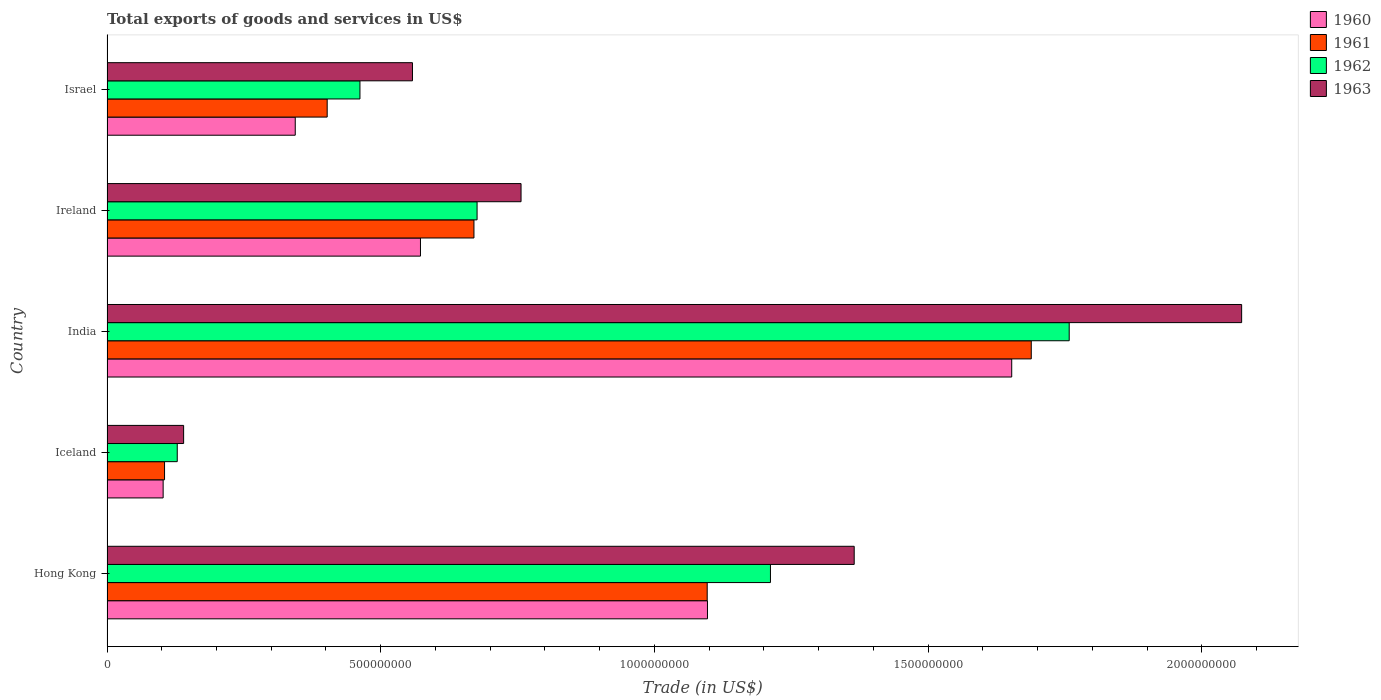How many different coloured bars are there?
Your answer should be compact. 4. How many groups of bars are there?
Offer a very short reply. 5. Are the number of bars on each tick of the Y-axis equal?
Give a very brief answer. Yes. How many bars are there on the 1st tick from the top?
Your response must be concise. 4. What is the label of the 4th group of bars from the top?
Offer a terse response. Iceland. What is the total exports of goods and services in 1960 in Israel?
Your answer should be very brief. 3.44e+08. Across all countries, what is the maximum total exports of goods and services in 1961?
Offer a terse response. 1.69e+09. Across all countries, what is the minimum total exports of goods and services in 1961?
Provide a succinct answer. 1.05e+08. In which country was the total exports of goods and services in 1960 maximum?
Provide a short and direct response. India. In which country was the total exports of goods and services in 1963 minimum?
Your response must be concise. Iceland. What is the total total exports of goods and services in 1961 in the graph?
Ensure brevity in your answer.  3.96e+09. What is the difference between the total exports of goods and services in 1963 in Hong Kong and that in Iceland?
Your answer should be compact. 1.22e+09. What is the difference between the total exports of goods and services in 1961 in India and the total exports of goods and services in 1963 in Iceland?
Provide a succinct answer. 1.55e+09. What is the average total exports of goods and services in 1962 per country?
Your answer should be compact. 8.47e+08. What is the difference between the total exports of goods and services in 1962 and total exports of goods and services in 1960 in Iceland?
Your answer should be very brief. 2.58e+07. What is the ratio of the total exports of goods and services in 1960 in Hong Kong to that in Iceland?
Provide a succinct answer. 10.7. Is the total exports of goods and services in 1962 in Hong Kong less than that in Ireland?
Make the answer very short. No. What is the difference between the highest and the second highest total exports of goods and services in 1963?
Make the answer very short. 7.08e+08. What is the difference between the highest and the lowest total exports of goods and services in 1962?
Offer a terse response. 1.63e+09. In how many countries, is the total exports of goods and services in 1961 greater than the average total exports of goods and services in 1961 taken over all countries?
Offer a terse response. 2. Is the sum of the total exports of goods and services in 1961 in India and Israel greater than the maximum total exports of goods and services in 1962 across all countries?
Ensure brevity in your answer.  Yes. What does the 1st bar from the top in Iceland represents?
Ensure brevity in your answer.  1963. What does the 1st bar from the bottom in Hong Kong represents?
Offer a terse response. 1960. Is it the case that in every country, the sum of the total exports of goods and services in 1963 and total exports of goods and services in 1962 is greater than the total exports of goods and services in 1961?
Your answer should be compact. Yes. How many bars are there?
Make the answer very short. 20. How many countries are there in the graph?
Your response must be concise. 5. What is the difference between two consecutive major ticks on the X-axis?
Your answer should be very brief. 5.00e+08. How are the legend labels stacked?
Your answer should be compact. Vertical. What is the title of the graph?
Your answer should be very brief. Total exports of goods and services in US$. What is the label or title of the X-axis?
Your answer should be very brief. Trade (in US$). What is the Trade (in US$) of 1960 in Hong Kong?
Provide a short and direct response. 1.10e+09. What is the Trade (in US$) in 1961 in Hong Kong?
Provide a short and direct response. 1.10e+09. What is the Trade (in US$) of 1962 in Hong Kong?
Ensure brevity in your answer.  1.21e+09. What is the Trade (in US$) in 1963 in Hong Kong?
Offer a very short reply. 1.36e+09. What is the Trade (in US$) in 1960 in Iceland?
Keep it short and to the point. 1.03e+08. What is the Trade (in US$) of 1961 in Iceland?
Your answer should be compact. 1.05e+08. What is the Trade (in US$) of 1962 in Iceland?
Your answer should be compact. 1.28e+08. What is the Trade (in US$) in 1963 in Iceland?
Your response must be concise. 1.40e+08. What is the Trade (in US$) of 1960 in India?
Give a very brief answer. 1.65e+09. What is the Trade (in US$) of 1961 in India?
Make the answer very short. 1.69e+09. What is the Trade (in US$) of 1962 in India?
Your answer should be very brief. 1.76e+09. What is the Trade (in US$) of 1963 in India?
Provide a short and direct response. 2.07e+09. What is the Trade (in US$) in 1960 in Ireland?
Ensure brevity in your answer.  5.73e+08. What is the Trade (in US$) in 1961 in Ireland?
Your answer should be compact. 6.70e+08. What is the Trade (in US$) of 1962 in Ireland?
Make the answer very short. 6.76e+08. What is the Trade (in US$) of 1963 in Ireland?
Provide a short and direct response. 7.56e+08. What is the Trade (in US$) in 1960 in Israel?
Your answer should be very brief. 3.44e+08. What is the Trade (in US$) of 1961 in Israel?
Make the answer very short. 4.02e+08. What is the Trade (in US$) in 1962 in Israel?
Provide a short and direct response. 4.62e+08. What is the Trade (in US$) of 1963 in Israel?
Your response must be concise. 5.58e+08. Across all countries, what is the maximum Trade (in US$) in 1960?
Make the answer very short. 1.65e+09. Across all countries, what is the maximum Trade (in US$) of 1961?
Your response must be concise. 1.69e+09. Across all countries, what is the maximum Trade (in US$) of 1962?
Provide a succinct answer. 1.76e+09. Across all countries, what is the maximum Trade (in US$) in 1963?
Keep it short and to the point. 2.07e+09. Across all countries, what is the minimum Trade (in US$) of 1960?
Give a very brief answer. 1.03e+08. Across all countries, what is the minimum Trade (in US$) in 1961?
Provide a succinct answer. 1.05e+08. Across all countries, what is the minimum Trade (in US$) in 1962?
Your answer should be compact. 1.28e+08. Across all countries, what is the minimum Trade (in US$) in 1963?
Keep it short and to the point. 1.40e+08. What is the total Trade (in US$) in 1960 in the graph?
Ensure brevity in your answer.  3.77e+09. What is the total Trade (in US$) in 1961 in the graph?
Make the answer very short. 3.96e+09. What is the total Trade (in US$) in 1962 in the graph?
Provide a short and direct response. 4.24e+09. What is the total Trade (in US$) in 1963 in the graph?
Ensure brevity in your answer.  4.89e+09. What is the difference between the Trade (in US$) in 1960 in Hong Kong and that in Iceland?
Your answer should be compact. 9.94e+08. What is the difference between the Trade (in US$) of 1961 in Hong Kong and that in Iceland?
Provide a short and direct response. 9.91e+08. What is the difference between the Trade (in US$) of 1962 in Hong Kong and that in Iceland?
Your response must be concise. 1.08e+09. What is the difference between the Trade (in US$) of 1963 in Hong Kong and that in Iceland?
Your response must be concise. 1.22e+09. What is the difference between the Trade (in US$) in 1960 in Hong Kong and that in India?
Keep it short and to the point. -5.56e+08. What is the difference between the Trade (in US$) of 1961 in Hong Kong and that in India?
Offer a very short reply. -5.92e+08. What is the difference between the Trade (in US$) of 1962 in Hong Kong and that in India?
Provide a succinct answer. -5.46e+08. What is the difference between the Trade (in US$) of 1963 in Hong Kong and that in India?
Provide a succinct answer. -7.08e+08. What is the difference between the Trade (in US$) in 1960 in Hong Kong and that in Ireland?
Offer a very short reply. 5.24e+08. What is the difference between the Trade (in US$) of 1961 in Hong Kong and that in Ireland?
Offer a terse response. 4.26e+08. What is the difference between the Trade (in US$) of 1962 in Hong Kong and that in Ireland?
Your answer should be very brief. 5.36e+08. What is the difference between the Trade (in US$) of 1963 in Hong Kong and that in Ireland?
Ensure brevity in your answer.  6.09e+08. What is the difference between the Trade (in US$) of 1960 in Hong Kong and that in Israel?
Make the answer very short. 7.53e+08. What is the difference between the Trade (in US$) of 1961 in Hong Kong and that in Israel?
Provide a short and direct response. 6.94e+08. What is the difference between the Trade (in US$) of 1962 in Hong Kong and that in Israel?
Offer a very short reply. 7.50e+08. What is the difference between the Trade (in US$) in 1963 in Hong Kong and that in Israel?
Your response must be concise. 8.07e+08. What is the difference between the Trade (in US$) of 1960 in Iceland and that in India?
Provide a succinct answer. -1.55e+09. What is the difference between the Trade (in US$) of 1961 in Iceland and that in India?
Your answer should be compact. -1.58e+09. What is the difference between the Trade (in US$) in 1962 in Iceland and that in India?
Give a very brief answer. -1.63e+09. What is the difference between the Trade (in US$) of 1963 in Iceland and that in India?
Offer a very short reply. -1.93e+09. What is the difference between the Trade (in US$) of 1960 in Iceland and that in Ireland?
Your answer should be very brief. -4.70e+08. What is the difference between the Trade (in US$) in 1961 in Iceland and that in Ireland?
Your response must be concise. -5.65e+08. What is the difference between the Trade (in US$) of 1962 in Iceland and that in Ireland?
Your answer should be compact. -5.48e+08. What is the difference between the Trade (in US$) in 1963 in Iceland and that in Ireland?
Your answer should be very brief. -6.16e+08. What is the difference between the Trade (in US$) in 1960 in Iceland and that in Israel?
Offer a terse response. -2.41e+08. What is the difference between the Trade (in US$) of 1961 in Iceland and that in Israel?
Give a very brief answer. -2.97e+08. What is the difference between the Trade (in US$) in 1962 in Iceland and that in Israel?
Give a very brief answer. -3.34e+08. What is the difference between the Trade (in US$) in 1963 in Iceland and that in Israel?
Your response must be concise. -4.18e+08. What is the difference between the Trade (in US$) of 1960 in India and that in Ireland?
Offer a terse response. 1.08e+09. What is the difference between the Trade (in US$) in 1961 in India and that in Ireland?
Your answer should be very brief. 1.02e+09. What is the difference between the Trade (in US$) in 1962 in India and that in Ireland?
Make the answer very short. 1.08e+09. What is the difference between the Trade (in US$) in 1963 in India and that in Ireland?
Ensure brevity in your answer.  1.32e+09. What is the difference between the Trade (in US$) of 1960 in India and that in Israel?
Your answer should be very brief. 1.31e+09. What is the difference between the Trade (in US$) of 1961 in India and that in Israel?
Offer a terse response. 1.29e+09. What is the difference between the Trade (in US$) in 1962 in India and that in Israel?
Provide a succinct answer. 1.30e+09. What is the difference between the Trade (in US$) of 1963 in India and that in Israel?
Keep it short and to the point. 1.51e+09. What is the difference between the Trade (in US$) in 1960 in Ireland and that in Israel?
Give a very brief answer. 2.29e+08. What is the difference between the Trade (in US$) in 1961 in Ireland and that in Israel?
Provide a succinct answer. 2.68e+08. What is the difference between the Trade (in US$) in 1962 in Ireland and that in Israel?
Your answer should be compact. 2.14e+08. What is the difference between the Trade (in US$) in 1963 in Ireland and that in Israel?
Make the answer very short. 1.98e+08. What is the difference between the Trade (in US$) in 1960 in Hong Kong and the Trade (in US$) in 1961 in Iceland?
Give a very brief answer. 9.92e+08. What is the difference between the Trade (in US$) of 1960 in Hong Kong and the Trade (in US$) of 1962 in Iceland?
Make the answer very short. 9.69e+08. What is the difference between the Trade (in US$) of 1960 in Hong Kong and the Trade (in US$) of 1963 in Iceland?
Provide a short and direct response. 9.57e+08. What is the difference between the Trade (in US$) of 1961 in Hong Kong and the Trade (in US$) of 1962 in Iceland?
Ensure brevity in your answer.  9.68e+08. What is the difference between the Trade (in US$) in 1961 in Hong Kong and the Trade (in US$) in 1963 in Iceland?
Ensure brevity in your answer.  9.56e+08. What is the difference between the Trade (in US$) of 1962 in Hong Kong and the Trade (in US$) of 1963 in Iceland?
Offer a very short reply. 1.07e+09. What is the difference between the Trade (in US$) in 1960 in Hong Kong and the Trade (in US$) in 1961 in India?
Offer a terse response. -5.91e+08. What is the difference between the Trade (in US$) in 1960 in Hong Kong and the Trade (in US$) in 1962 in India?
Your answer should be compact. -6.61e+08. What is the difference between the Trade (in US$) in 1960 in Hong Kong and the Trade (in US$) in 1963 in India?
Your response must be concise. -9.76e+08. What is the difference between the Trade (in US$) of 1961 in Hong Kong and the Trade (in US$) of 1962 in India?
Offer a very short reply. -6.61e+08. What is the difference between the Trade (in US$) of 1961 in Hong Kong and the Trade (in US$) of 1963 in India?
Your response must be concise. -9.76e+08. What is the difference between the Trade (in US$) of 1962 in Hong Kong and the Trade (in US$) of 1963 in India?
Your answer should be compact. -8.61e+08. What is the difference between the Trade (in US$) in 1960 in Hong Kong and the Trade (in US$) in 1961 in Ireland?
Offer a very short reply. 4.27e+08. What is the difference between the Trade (in US$) of 1960 in Hong Kong and the Trade (in US$) of 1962 in Ireland?
Provide a succinct answer. 4.21e+08. What is the difference between the Trade (in US$) of 1960 in Hong Kong and the Trade (in US$) of 1963 in Ireland?
Provide a short and direct response. 3.41e+08. What is the difference between the Trade (in US$) of 1961 in Hong Kong and the Trade (in US$) of 1962 in Ireland?
Your answer should be very brief. 4.20e+08. What is the difference between the Trade (in US$) of 1961 in Hong Kong and the Trade (in US$) of 1963 in Ireland?
Offer a terse response. 3.40e+08. What is the difference between the Trade (in US$) in 1962 in Hong Kong and the Trade (in US$) in 1963 in Ireland?
Your answer should be very brief. 4.56e+08. What is the difference between the Trade (in US$) of 1960 in Hong Kong and the Trade (in US$) of 1961 in Israel?
Offer a terse response. 6.95e+08. What is the difference between the Trade (in US$) in 1960 in Hong Kong and the Trade (in US$) in 1962 in Israel?
Your answer should be very brief. 6.35e+08. What is the difference between the Trade (in US$) of 1960 in Hong Kong and the Trade (in US$) of 1963 in Israel?
Offer a very short reply. 5.39e+08. What is the difference between the Trade (in US$) of 1961 in Hong Kong and the Trade (in US$) of 1962 in Israel?
Offer a terse response. 6.34e+08. What is the difference between the Trade (in US$) of 1961 in Hong Kong and the Trade (in US$) of 1963 in Israel?
Ensure brevity in your answer.  5.38e+08. What is the difference between the Trade (in US$) in 1962 in Hong Kong and the Trade (in US$) in 1963 in Israel?
Your answer should be very brief. 6.54e+08. What is the difference between the Trade (in US$) of 1960 in Iceland and the Trade (in US$) of 1961 in India?
Provide a succinct answer. -1.59e+09. What is the difference between the Trade (in US$) of 1960 in Iceland and the Trade (in US$) of 1962 in India?
Provide a short and direct response. -1.66e+09. What is the difference between the Trade (in US$) of 1960 in Iceland and the Trade (in US$) of 1963 in India?
Your answer should be compact. -1.97e+09. What is the difference between the Trade (in US$) of 1961 in Iceland and the Trade (in US$) of 1962 in India?
Ensure brevity in your answer.  -1.65e+09. What is the difference between the Trade (in US$) in 1961 in Iceland and the Trade (in US$) in 1963 in India?
Give a very brief answer. -1.97e+09. What is the difference between the Trade (in US$) in 1962 in Iceland and the Trade (in US$) in 1963 in India?
Provide a short and direct response. -1.94e+09. What is the difference between the Trade (in US$) in 1960 in Iceland and the Trade (in US$) in 1961 in Ireland?
Keep it short and to the point. -5.68e+08. What is the difference between the Trade (in US$) of 1960 in Iceland and the Trade (in US$) of 1962 in Ireland?
Provide a short and direct response. -5.73e+08. What is the difference between the Trade (in US$) in 1960 in Iceland and the Trade (in US$) in 1963 in Ireland?
Your answer should be very brief. -6.54e+08. What is the difference between the Trade (in US$) in 1961 in Iceland and the Trade (in US$) in 1962 in Ireland?
Keep it short and to the point. -5.71e+08. What is the difference between the Trade (in US$) of 1961 in Iceland and the Trade (in US$) of 1963 in Ireland?
Offer a very short reply. -6.51e+08. What is the difference between the Trade (in US$) in 1962 in Iceland and the Trade (in US$) in 1963 in Ireland?
Your answer should be compact. -6.28e+08. What is the difference between the Trade (in US$) in 1960 in Iceland and the Trade (in US$) in 1961 in Israel?
Offer a terse response. -3.00e+08. What is the difference between the Trade (in US$) in 1960 in Iceland and the Trade (in US$) in 1962 in Israel?
Your answer should be very brief. -3.60e+08. What is the difference between the Trade (in US$) in 1960 in Iceland and the Trade (in US$) in 1963 in Israel?
Your answer should be compact. -4.55e+08. What is the difference between the Trade (in US$) of 1961 in Iceland and the Trade (in US$) of 1962 in Israel?
Your answer should be very brief. -3.57e+08. What is the difference between the Trade (in US$) in 1961 in Iceland and the Trade (in US$) in 1963 in Israel?
Make the answer very short. -4.53e+08. What is the difference between the Trade (in US$) in 1962 in Iceland and the Trade (in US$) in 1963 in Israel?
Keep it short and to the point. -4.30e+08. What is the difference between the Trade (in US$) of 1960 in India and the Trade (in US$) of 1961 in Ireland?
Your response must be concise. 9.82e+08. What is the difference between the Trade (in US$) in 1960 in India and the Trade (in US$) in 1962 in Ireland?
Provide a succinct answer. 9.77e+08. What is the difference between the Trade (in US$) in 1960 in India and the Trade (in US$) in 1963 in Ireland?
Ensure brevity in your answer.  8.96e+08. What is the difference between the Trade (in US$) of 1961 in India and the Trade (in US$) of 1962 in Ireland?
Your answer should be very brief. 1.01e+09. What is the difference between the Trade (in US$) of 1961 in India and the Trade (in US$) of 1963 in Ireland?
Offer a very short reply. 9.32e+08. What is the difference between the Trade (in US$) in 1962 in India and the Trade (in US$) in 1963 in Ireland?
Your answer should be compact. 1.00e+09. What is the difference between the Trade (in US$) in 1960 in India and the Trade (in US$) in 1961 in Israel?
Ensure brevity in your answer.  1.25e+09. What is the difference between the Trade (in US$) of 1960 in India and the Trade (in US$) of 1962 in Israel?
Provide a succinct answer. 1.19e+09. What is the difference between the Trade (in US$) in 1960 in India and the Trade (in US$) in 1963 in Israel?
Offer a very short reply. 1.09e+09. What is the difference between the Trade (in US$) of 1961 in India and the Trade (in US$) of 1962 in Israel?
Provide a short and direct response. 1.23e+09. What is the difference between the Trade (in US$) in 1961 in India and the Trade (in US$) in 1963 in Israel?
Offer a terse response. 1.13e+09. What is the difference between the Trade (in US$) in 1962 in India and the Trade (in US$) in 1963 in Israel?
Give a very brief answer. 1.20e+09. What is the difference between the Trade (in US$) of 1960 in Ireland and the Trade (in US$) of 1961 in Israel?
Ensure brevity in your answer.  1.70e+08. What is the difference between the Trade (in US$) in 1960 in Ireland and the Trade (in US$) in 1962 in Israel?
Keep it short and to the point. 1.11e+08. What is the difference between the Trade (in US$) in 1960 in Ireland and the Trade (in US$) in 1963 in Israel?
Ensure brevity in your answer.  1.46e+07. What is the difference between the Trade (in US$) of 1961 in Ireland and the Trade (in US$) of 1962 in Israel?
Provide a short and direct response. 2.08e+08. What is the difference between the Trade (in US$) of 1961 in Ireland and the Trade (in US$) of 1963 in Israel?
Keep it short and to the point. 1.12e+08. What is the difference between the Trade (in US$) of 1962 in Ireland and the Trade (in US$) of 1963 in Israel?
Your answer should be compact. 1.18e+08. What is the average Trade (in US$) of 1960 per country?
Provide a succinct answer. 7.54e+08. What is the average Trade (in US$) of 1961 per country?
Offer a terse response. 7.92e+08. What is the average Trade (in US$) of 1962 per country?
Provide a short and direct response. 8.47e+08. What is the average Trade (in US$) of 1963 per country?
Provide a short and direct response. 9.78e+08. What is the difference between the Trade (in US$) in 1960 and Trade (in US$) in 1961 in Hong Kong?
Provide a short and direct response. 4.96e+05. What is the difference between the Trade (in US$) in 1960 and Trade (in US$) in 1962 in Hong Kong?
Your answer should be compact. -1.15e+08. What is the difference between the Trade (in US$) in 1960 and Trade (in US$) in 1963 in Hong Kong?
Make the answer very short. -2.68e+08. What is the difference between the Trade (in US$) of 1961 and Trade (in US$) of 1962 in Hong Kong?
Your response must be concise. -1.16e+08. What is the difference between the Trade (in US$) in 1961 and Trade (in US$) in 1963 in Hong Kong?
Your answer should be compact. -2.69e+08. What is the difference between the Trade (in US$) of 1962 and Trade (in US$) of 1963 in Hong Kong?
Offer a very short reply. -1.53e+08. What is the difference between the Trade (in US$) in 1960 and Trade (in US$) in 1961 in Iceland?
Provide a succinct answer. -2.55e+06. What is the difference between the Trade (in US$) in 1960 and Trade (in US$) in 1962 in Iceland?
Keep it short and to the point. -2.58e+07. What is the difference between the Trade (in US$) of 1960 and Trade (in US$) of 1963 in Iceland?
Provide a succinct answer. -3.74e+07. What is the difference between the Trade (in US$) of 1961 and Trade (in US$) of 1962 in Iceland?
Provide a succinct answer. -2.32e+07. What is the difference between the Trade (in US$) in 1961 and Trade (in US$) in 1963 in Iceland?
Provide a short and direct response. -3.49e+07. What is the difference between the Trade (in US$) in 1962 and Trade (in US$) in 1963 in Iceland?
Provide a succinct answer. -1.17e+07. What is the difference between the Trade (in US$) of 1960 and Trade (in US$) of 1961 in India?
Offer a very short reply. -3.57e+07. What is the difference between the Trade (in US$) in 1960 and Trade (in US$) in 1962 in India?
Keep it short and to the point. -1.05e+08. What is the difference between the Trade (in US$) of 1960 and Trade (in US$) of 1963 in India?
Give a very brief answer. -4.20e+08. What is the difference between the Trade (in US$) in 1961 and Trade (in US$) in 1962 in India?
Give a very brief answer. -6.93e+07. What is the difference between the Trade (in US$) of 1961 and Trade (in US$) of 1963 in India?
Ensure brevity in your answer.  -3.84e+08. What is the difference between the Trade (in US$) of 1962 and Trade (in US$) of 1963 in India?
Provide a succinct answer. -3.15e+08. What is the difference between the Trade (in US$) of 1960 and Trade (in US$) of 1961 in Ireland?
Ensure brevity in your answer.  -9.77e+07. What is the difference between the Trade (in US$) of 1960 and Trade (in US$) of 1962 in Ireland?
Offer a terse response. -1.03e+08. What is the difference between the Trade (in US$) in 1960 and Trade (in US$) in 1963 in Ireland?
Provide a succinct answer. -1.84e+08. What is the difference between the Trade (in US$) of 1961 and Trade (in US$) of 1962 in Ireland?
Offer a very short reply. -5.70e+06. What is the difference between the Trade (in US$) of 1961 and Trade (in US$) of 1963 in Ireland?
Your answer should be compact. -8.60e+07. What is the difference between the Trade (in US$) of 1962 and Trade (in US$) of 1963 in Ireland?
Offer a very short reply. -8.03e+07. What is the difference between the Trade (in US$) of 1960 and Trade (in US$) of 1961 in Israel?
Give a very brief answer. -5.83e+07. What is the difference between the Trade (in US$) in 1960 and Trade (in US$) in 1962 in Israel?
Your response must be concise. -1.18e+08. What is the difference between the Trade (in US$) of 1960 and Trade (in US$) of 1963 in Israel?
Your answer should be very brief. -2.14e+08. What is the difference between the Trade (in US$) of 1961 and Trade (in US$) of 1962 in Israel?
Your answer should be compact. -5.98e+07. What is the difference between the Trade (in US$) in 1961 and Trade (in US$) in 1963 in Israel?
Ensure brevity in your answer.  -1.56e+08. What is the difference between the Trade (in US$) of 1962 and Trade (in US$) of 1963 in Israel?
Keep it short and to the point. -9.59e+07. What is the ratio of the Trade (in US$) of 1960 in Hong Kong to that in Iceland?
Your answer should be very brief. 10.7. What is the ratio of the Trade (in US$) in 1961 in Hong Kong to that in Iceland?
Ensure brevity in your answer.  10.43. What is the ratio of the Trade (in US$) of 1962 in Hong Kong to that in Iceland?
Provide a succinct answer. 9.45. What is the ratio of the Trade (in US$) of 1963 in Hong Kong to that in Iceland?
Your answer should be compact. 9.75. What is the ratio of the Trade (in US$) of 1960 in Hong Kong to that in India?
Make the answer very short. 0.66. What is the ratio of the Trade (in US$) in 1961 in Hong Kong to that in India?
Make the answer very short. 0.65. What is the ratio of the Trade (in US$) in 1962 in Hong Kong to that in India?
Give a very brief answer. 0.69. What is the ratio of the Trade (in US$) of 1963 in Hong Kong to that in India?
Ensure brevity in your answer.  0.66. What is the ratio of the Trade (in US$) of 1960 in Hong Kong to that in Ireland?
Your answer should be compact. 1.92. What is the ratio of the Trade (in US$) in 1961 in Hong Kong to that in Ireland?
Offer a very short reply. 1.64. What is the ratio of the Trade (in US$) of 1962 in Hong Kong to that in Ireland?
Offer a terse response. 1.79. What is the ratio of the Trade (in US$) of 1963 in Hong Kong to that in Ireland?
Offer a very short reply. 1.8. What is the ratio of the Trade (in US$) in 1960 in Hong Kong to that in Israel?
Give a very brief answer. 3.19. What is the ratio of the Trade (in US$) in 1961 in Hong Kong to that in Israel?
Offer a terse response. 2.73. What is the ratio of the Trade (in US$) of 1962 in Hong Kong to that in Israel?
Your response must be concise. 2.62. What is the ratio of the Trade (in US$) in 1963 in Hong Kong to that in Israel?
Provide a succinct answer. 2.45. What is the ratio of the Trade (in US$) in 1960 in Iceland to that in India?
Offer a very short reply. 0.06. What is the ratio of the Trade (in US$) in 1961 in Iceland to that in India?
Keep it short and to the point. 0.06. What is the ratio of the Trade (in US$) in 1962 in Iceland to that in India?
Your answer should be compact. 0.07. What is the ratio of the Trade (in US$) in 1963 in Iceland to that in India?
Ensure brevity in your answer.  0.07. What is the ratio of the Trade (in US$) in 1960 in Iceland to that in Ireland?
Provide a short and direct response. 0.18. What is the ratio of the Trade (in US$) in 1961 in Iceland to that in Ireland?
Keep it short and to the point. 0.16. What is the ratio of the Trade (in US$) of 1962 in Iceland to that in Ireland?
Ensure brevity in your answer.  0.19. What is the ratio of the Trade (in US$) of 1963 in Iceland to that in Ireland?
Make the answer very short. 0.19. What is the ratio of the Trade (in US$) of 1960 in Iceland to that in Israel?
Keep it short and to the point. 0.3. What is the ratio of the Trade (in US$) in 1961 in Iceland to that in Israel?
Provide a short and direct response. 0.26. What is the ratio of the Trade (in US$) in 1962 in Iceland to that in Israel?
Your answer should be compact. 0.28. What is the ratio of the Trade (in US$) in 1963 in Iceland to that in Israel?
Provide a short and direct response. 0.25. What is the ratio of the Trade (in US$) of 1960 in India to that in Ireland?
Offer a very short reply. 2.89. What is the ratio of the Trade (in US$) of 1961 in India to that in Ireland?
Give a very brief answer. 2.52. What is the ratio of the Trade (in US$) of 1962 in India to that in Ireland?
Provide a succinct answer. 2.6. What is the ratio of the Trade (in US$) of 1963 in India to that in Ireland?
Provide a succinct answer. 2.74. What is the ratio of the Trade (in US$) in 1960 in India to that in Israel?
Keep it short and to the point. 4.81. What is the ratio of the Trade (in US$) in 1961 in India to that in Israel?
Provide a short and direct response. 4.2. What is the ratio of the Trade (in US$) of 1962 in India to that in Israel?
Offer a very short reply. 3.8. What is the ratio of the Trade (in US$) in 1963 in India to that in Israel?
Offer a terse response. 3.71. What is the ratio of the Trade (in US$) of 1960 in Ireland to that in Israel?
Provide a succinct answer. 1.67. What is the ratio of the Trade (in US$) of 1961 in Ireland to that in Israel?
Make the answer very short. 1.67. What is the ratio of the Trade (in US$) of 1962 in Ireland to that in Israel?
Your answer should be compact. 1.46. What is the ratio of the Trade (in US$) of 1963 in Ireland to that in Israel?
Your answer should be very brief. 1.36. What is the difference between the highest and the second highest Trade (in US$) in 1960?
Provide a short and direct response. 5.56e+08. What is the difference between the highest and the second highest Trade (in US$) of 1961?
Provide a short and direct response. 5.92e+08. What is the difference between the highest and the second highest Trade (in US$) in 1962?
Your response must be concise. 5.46e+08. What is the difference between the highest and the second highest Trade (in US$) of 1963?
Provide a succinct answer. 7.08e+08. What is the difference between the highest and the lowest Trade (in US$) of 1960?
Provide a succinct answer. 1.55e+09. What is the difference between the highest and the lowest Trade (in US$) of 1961?
Ensure brevity in your answer.  1.58e+09. What is the difference between the highest and the lowest Trade (in US$) in 1962?
Ensure brevity in your answer.  1.63e+09. What is the difference between the highest and the lowest Trade (in US$) of 1963?
Ensure brevity in your answer.  1.93e+09. 